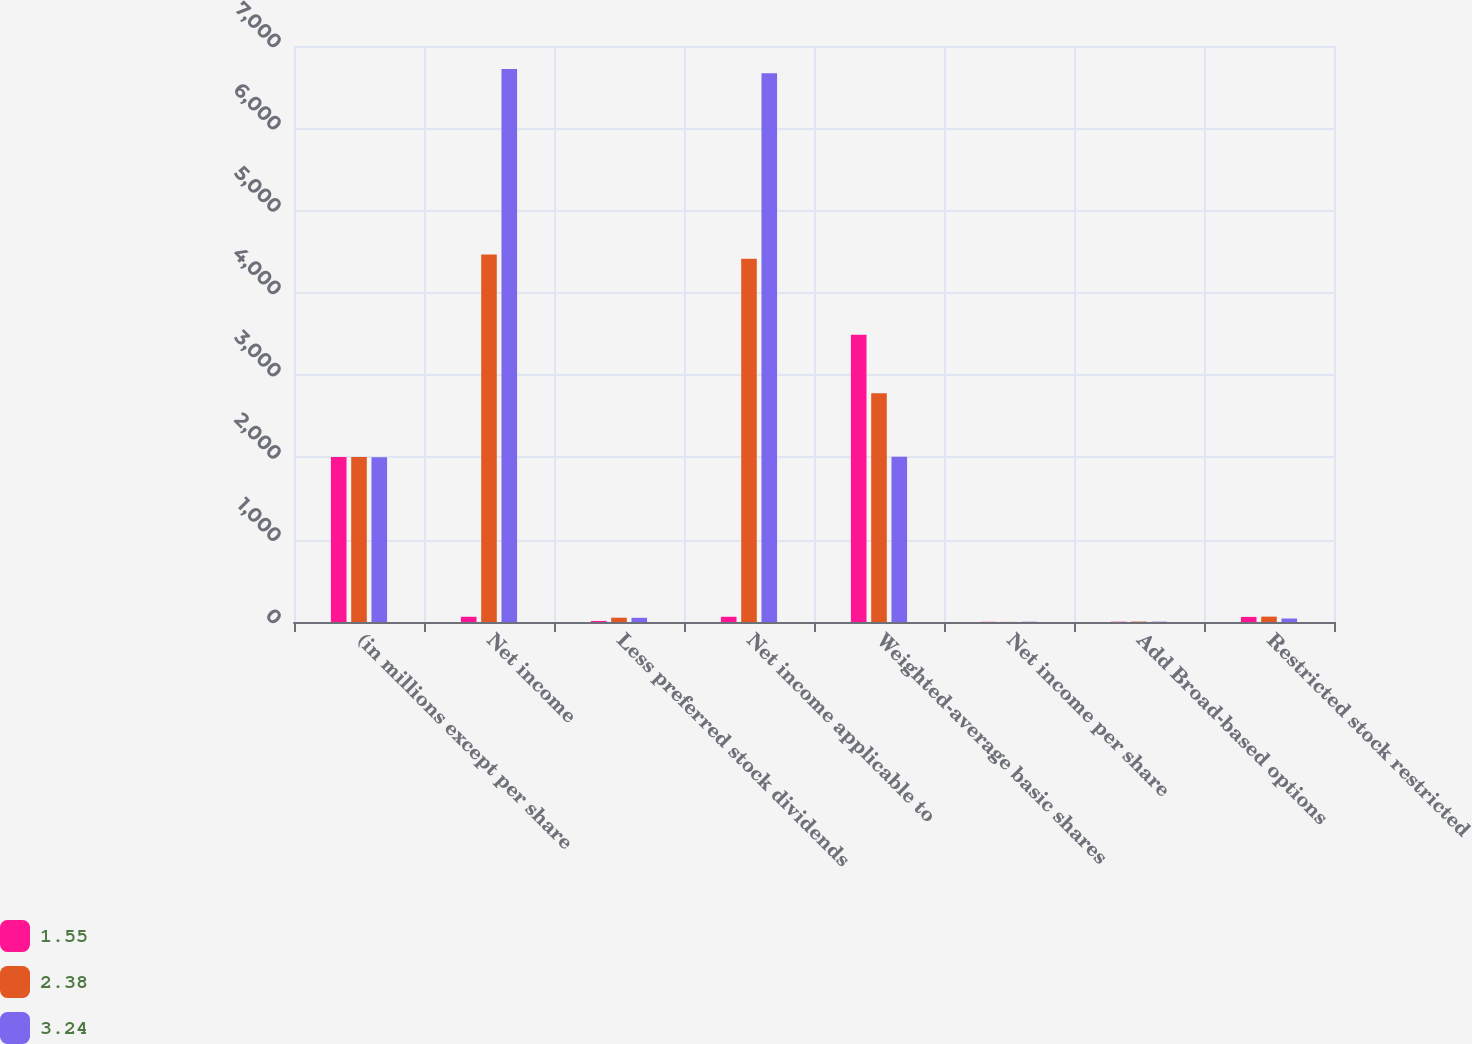<chart> <loc_0><loc_0><loc_500><loc_500><stacked_bar_chart><ecel><fcel>(in millions except per share<fcel>Net income<fcel>Less preferred stock dividends<fcel>Net income applicable to<fcel>Weighted-average basic shares<fcel>Net income per share<fcel>Add Broad-based options<fcel>Restricted stock restricted<nl><fcel>1.55<fcel>2005<fcel>63.65<fcel>13<fcel>63.65<fcel>3491.7<fcel>2.43<fcel>3.6<fcel>62<nl><fcel>2.38<fcel>2004<fcel>4466<fcel>52<fcel>4414<fcel>2779.9<fcel>1.59<fcel>5.4<fcel>65.3<nl><fcel>3.24<fcel>2003<fcel>6719<fcel>51<fcel>6668<fcel>2008.6<fcel>3.32<fcel>4.1<fcel>42.4<nl></chart> 